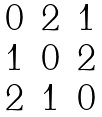<formula> <loc_0><loc_0><loc_500><loc_500>\begin{array} { c c c } 0 & 2 & 1 \\ 1 & 0 & 2 \\ 2 & 1 & 0 \end{array}</formula> 